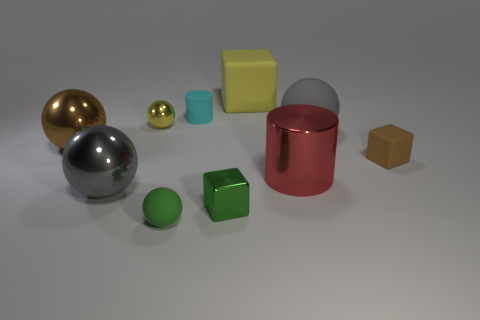Subtract all yellow spheres. How many spheres are left? 4 Subtract all big brown balls. How many balls are left? 4 Subtract 1 spheres. How many spheres are left? 4 Subtract all purple balls. Subtract all green cylinders. How many balls are left? 5 Subtract all cubes. How many objects are left? 7 Subtract all tiny brown rubber balls. Subtract all metal objects. How many objects are left? 5 Add 6 gray balls. How many gray balls are left? 8 Add 1 large blue metal things. How many large blue metal things exist? 1 Subtract 1 brown balls. How many objects are left? 9 